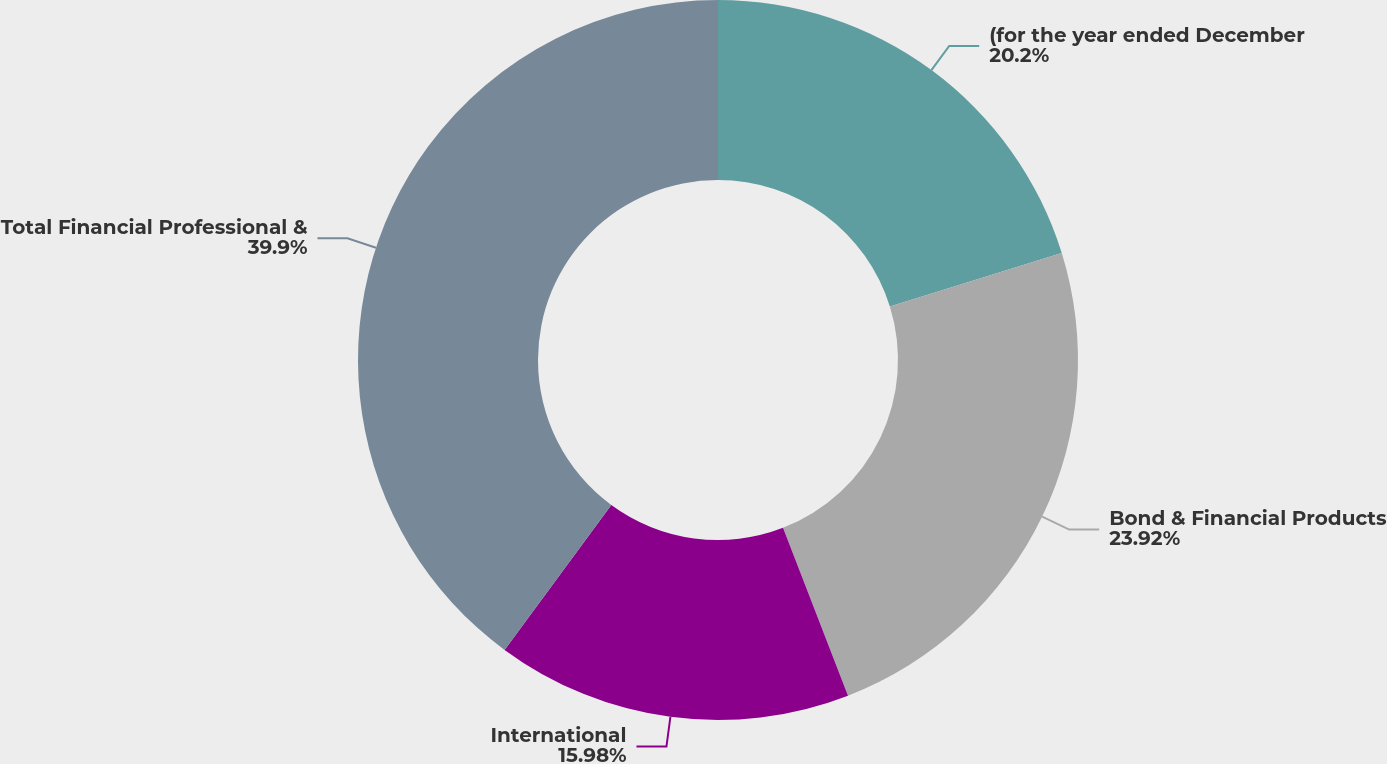Convert chart to OTSL. <chart><loc_0><loc_0><loc_500><loc_500><pie_chart><fcel>(for the year ended December<fcel>Bond & Financial Products<fcel>International<fcel>Total Financial Professional &<nl><fcel>20.2%<fcel>23.92%<fcel>15.98%<fcel>39.9%<nl></chart> 